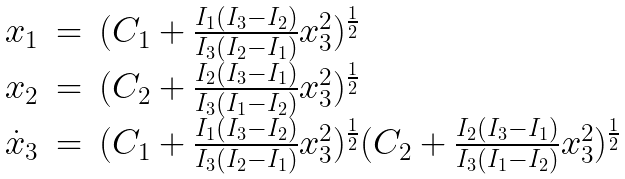Convert formula to latex. <formula><loc_0><loc_0><loc_500><loc_500>\begin{array} { l l l } x _ { 1 } & = & ( C _ { 1 } + \frac { I _ { 1 } ( I _ { 3 } - I _ { 2 } ) } { I _ { 3 } ( I _ { 2 } - I _ { 1 } ) } x _ { 3 } ^ { 2 } ) ^ { \frac { 1 } { 2 } } \\ x _ { 2 } & = & ( C _ { 2 } + \frac { I _ { 2 } ( I _ { 3 } - I _ { 1 } ) } { I _ { 3 } ( I _ { 1 } - I _ { 2 } ) } x _ { 3 } ^ { 2 } ) ^ { \frac { 1 } { 2 } } \\ \dot { x } _ { 3 } & = & ( C _ { 1 } + \frac { I _ { 1 } ( I _ { 3 } - I _ { 2 } ) } { I _ { 3 } ( I _ { 2 } - I _ { 1 } ) } x _ { 3 } ^ { 2 } ) ^ { \frac { 1 } { 2 } } ( C _ { 2 } + \frac { I _ { 2 } ( I _ { 3 } - I _ { 1 } ) } { I _ { 3 } ( I _ { 1 } - I _ { 2 } ) } x _ { 3 } ^ { 2 } ) ^ { \frac { 1 } { 2 } } \\ \end{array}</formula> 